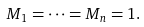<formula> <loc_0><loc_0><loc_500><loc_500>M _ { 1 } = \cdots = M _ { n } = 1 .</formula> 